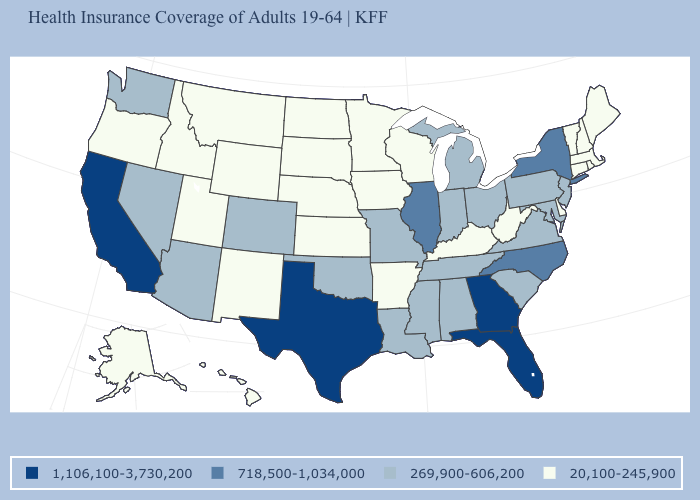Does Illinois have the highest value in the MidWest?
Quick response, please. Yes. How many symbols are there in the legend?
Answer briefly. 4. What is the value of North Dakota?
Concise answer only. 20,100-245,900. Does Louisiana have the same value as Montana?
Concise answer only. No. Does the first symbol in the legend represent the smallest category?
Short answer required. No. Name the states that have a value in the range 718,500-1,034,000?
Answer briefly. Illinois, New York, North Carolina. How many symbols are there in the legend?
Write a very short answer. 4. What is the lowest value in the USA?
Short answer required. 20,100-245,900. Does the map have missing data?
Be succinct. No. How many symbols are there in the legend?
Be succinct. 4. What is the value of Massachusetts?
Quick response, please. 20,100-245,900. Name the states that have a value in the range 20,100-245,900?
Concise answer only. Alaska, Arkansas, Connecticut, Delaware, Hawaii, Idaho, Iowa, Kansas, Kentucky, Maine, Massachusetts, Minnesota, Montana, Nebraska, New Hampshire, New Mexico, North Dakota, Oregon, Rhode Island, South Dakota, Utah, Vermont, West Virginia, Wisconsin, Wyoming. Among the states that border Michigan , does Ohio have the lowest value?
Be succinct. No. What is the value of Kentucky?
Quick response, please. 20,100-245,900. Name the states that have a value in the range 718,500-1,034,000?
Be succinct. Illinois, New York, North Carolina. 